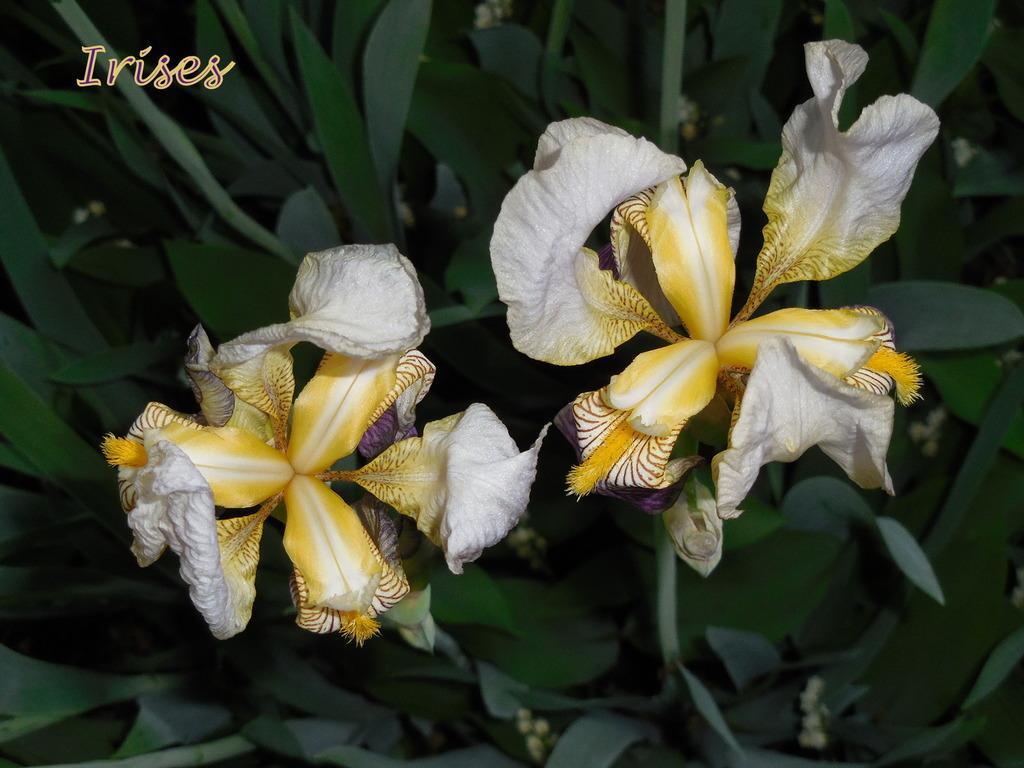Please provide a concise description of this image. There is a plant with two flowers and on the left at the top corner there is a text. 